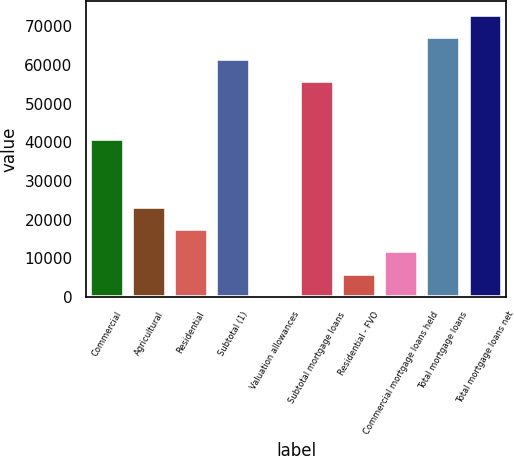<chart> <loc_0><loc_0><loc_500><loc_500><bar_chart><fcel>Commercial<fcel>Agricultural<fcel>Residential<fcel>Subtotal (1)<fcel>Valuation allowances<fcel>Subtotal mortgage loans<fcel>Residential - FVO<fcel>Commercial mortgage loans held<fcel>Total mortgage loans<fcel>Total mortgage loans net<nl><fcel>40926<fcel>23275.6<fcel>17537.2<fcel>61505.4<fcel>322<fcel>55767<fcel>6060.4<fcel>11798.8<fcel>67243.8<fcel>72982.2<nl></chart> 